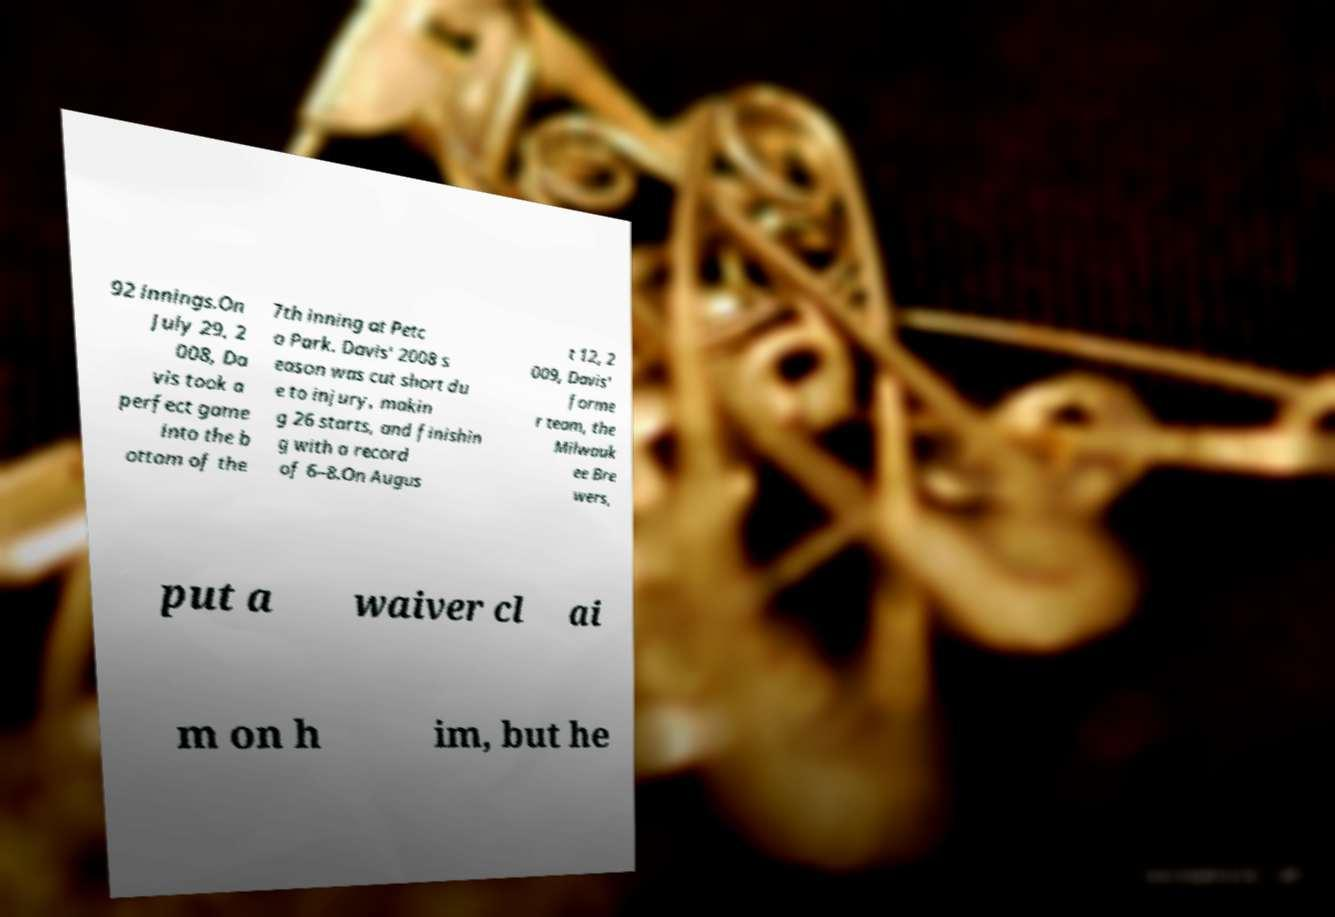There's text embedded in this image that I need extracted. Can you transcribe it verbatim? 92 innings.On July 29, 2 008, Da vis took a perfect game into the b ottom of the 7th inning at Petc o Park. Davis' 2008 s eason was cut short du e to injury, makin g 26 starts, and finishin g with a record of 6–8.On Augus t 12, 2 009, Davis' forme r team, the Milwauk ee Bre wers, put a waiver cl ai m on h im, but he 